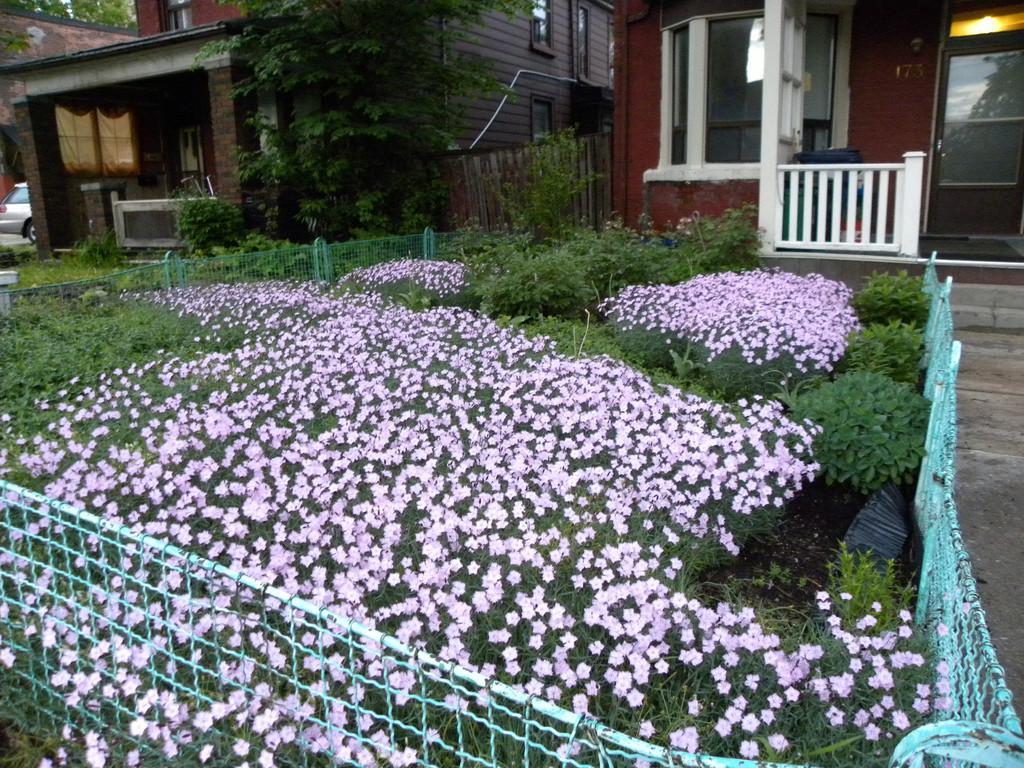In one or two sentences, can you explain what this image depicts? In this image, I can see the plants with the flowers and a fence. In the background, I can see the buildings with the windows and doors. On the right side of the image, there is a pathway. On the left corner of the image, there is a vehicle. 